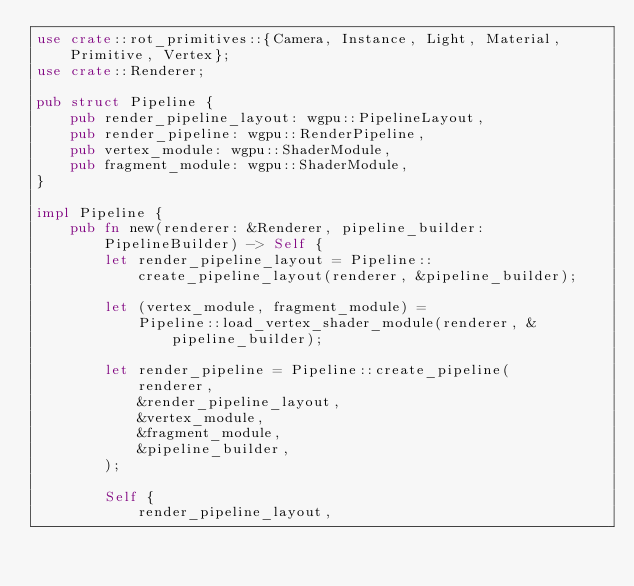Convert code to text. <code><loc_0><loc_0><loc_500><loc_500><_Rust_>use crate::rot_primitives::{Camera, Instance, Light, Material, Primitive, Vertex};
use crate::Renderer;

pub struct Pipeline {
    pub render_pipeline_layout: wgpu::PipelineLayout,
    pub render_pipeline: wgpu::RenderPipeline,
    pub vertex_module: wgpu::ShaderModule,
    pub fragment_module: wgpu::ShaderModule,
}

impl Pipeline {
    pub fn new(renderer: &Renderer, pipeline_builder: PipelineBuilder) -> Self {
        let render_pipeline_layout = Pipeline::create_pipeline_layout(renderer, &pipeline_builder);

        let (vertex_module, fragment_module) =
            Pipeline::load_vertex_shader_module(renderer, &pipeline_builder);

        let render_pipeline = Pipeline::create_pipeline(
            renderer,
            &render_pipeline_layout,
            &vertex_module,
            &fragment_module,
            &pipeline_builder,
        );

        Self {
            render_pipeline_layout,</code> 